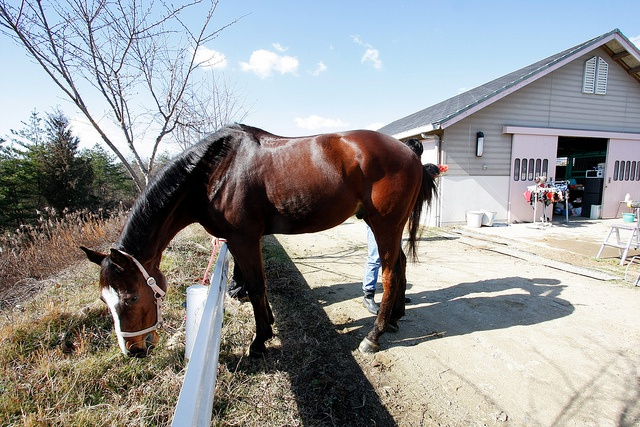Describe the objects in this image and their specific colors. I can see horse in darkgray, black, maroon, and gray tones and people in darkgray, white, lightblue, and black tones in this image. 